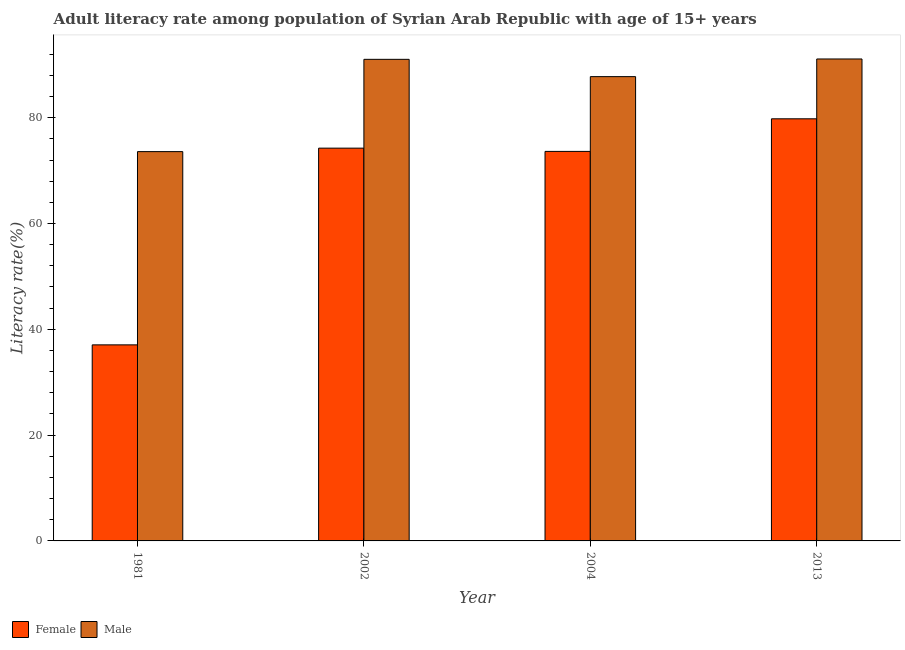How many different coloured bars are there?
Ensure brevity in your answer.  2. How many groups of bars are there?
Give a very brief answer. 4. Are the number of bars on each tick of the X-axis equal?
Give a very brief answer. Yes. How many bars are there on the 2nd tick from the left?
Ensure brevity in your answer.  2. What is the label of the 1st group of bars from the left?
Your response must be concise. 1981. In how many cases, is the number of bars for a given year not equal to the number of legend labels?
Provide a succinct answer. 0. What is the male adult literacy rate in 2002?
Your response must be concise. 91.03. Across all years, what is the maximum female adult literacy rate?
Your response must be concise. 79.79. Across all years, what is the minimum female adult literacy rate?
Make the answer very short. 37.06. What is the total male adult literacy rate in the graph?
Provide a succinct answer. 343.47. What is the difference between the male adult literacy rate in 2004 and that in 2013?
Make the answer very short. -3.34. What is the difference between the female adult literacy rate in 1981 and the male adult literacy rate in 2002?
Give a very brief answer. -37.18. What is the average female adult literacy rate per year?
Your response must be concise. 66.18. In the year 2004, what is the difference between the female adult literacy rate and male adult literacy rate?
Provide a succinct answer. 0. What is the ratio of the male adult literacy rate in 2002 to that in 2004?
Offer a terse response. 1.04. Is the female adult literacy rate in 1981 less than that in 2004?
Offer a very short reply. Yes. What is the difference between the highest and the second highest female adult literacy rate?
Provide a short and direct response. 5.55. What is the difference between the highest and the lowest female adult literacy rate?
Keep it short and to the point. 42.73. In how many years, is the female adult literacy rate greater than the average female adult literacy rate taken over all years?
Provide a short and direct response. 3. Is the sum of the male adult literacy rate in 2002 and 2004 greater than the maximum female adult literacy rate across all years?
Offer a terse response. Yes. What does the 2nd bar from the right in 2002 represents?
Give a very brief answer. Female. How many bars are there?
Offer a terse response. 8. Are all the bars in the graph horizontal?
Provide a short and direct response. No. Does the graph contain grids?
Make the answer very short. No. Where does the legend appear in the graph?
Provide a succinct answer. Bottom left. How many legend labels are there?
Provide a short and direct response. 2. What is the title of the graph?
Give a very brief answer. Adult literacy rate among population of Syrian Arab Republic with age of 15+ years. Does "Time to import" appear as one of the legend labels in the graph?
Provide a succinct answer. No. What is the label or title of the X-axis?
Give a very brief answer. Year. What is the label or title of the Y-axis?
Keep it short and to the point. Literacy rate(%). What is the Literacy rate(%) in Female in 1981?
Keep it short and to the point. 37.06. What is the Literacy rate(%) in Male in 1981?
Ensure brevity in your answer.  73.58. What is the Literacy rate(%) in Female in 2002?
Offer a very short reply. 74.24. What is the Literacy rate(%) of Male in 2002?
Give a very brief answer. 91.03. What is the Literacy rate(%) in Female in 2004?
Offer a terse response. 73.63. What is the Literacy rate(%) of Male in 2004?
Your answer should be very brief. 87.76. What is the Literacy rate(%) of Female in 2013?
Keep it short and to the point. 79.79. What is the Literacy rate(%) in Male in 2013?
Make the answer very short. 91.1. Across all years, what is the maximum Literacy rate(%) of Female?
Offer a terse response. 79.79. Across all years, what is the maximum Literacy rate(%) of Male?
Offer a very short reply. 91.1. Across all years, what is the minimum Literacy rate(%) in Female?
Give a very brief answer. 37.06. Across all years, what is the minimum Literacy rate(%) in Male?
Make the answer very short. 73.58. What is the total Literacy rate(%) in Female in the graph?
Ensure brevity in your answer.  264.71. What is the total Literacy rate(%) in Male in the graph?
Provide a short and direct response. 343.47. What is the difference between the Literacy rate(%) of Female in 1981 and that in 2002?
Your answer should be very brief. -37.18. What is the difference between the Literacy rate(%) in Male in 1981 and that in 2002?
Offer a very short reply. -17.44. What is the difference between the Literacy rate(%) of Female in 1981 and that in 2004?
Provide a short and direct response. -36.57. What is the difference between the Literacy rate(%) in Male in 1981 and that in 2004?
Offer a terse response. -14.17. What is the difference between the Literacy rate(%) in Female in 1981 and that in 2013?
Provide a short and direct response. -42.73. What is the difference between the Literacy rate(%) in Male in 1981 and that in 2013?
Give a very brief answer. -17.51. What is the difference between the Literacy rate(%) of Female in 2002 and that in 2004?
Provide a succinct answer. 0.61. What is the difference between the Literacy rate(%) of Male in 2002 and that in 2004?
Your answer should be very brief. 3.27. What is the difference between the Literacy rate(%) of Female in 2002 and that in 2013?
Make the answer very short. -5.55. What is the difference between the Literacy rate(%) in Male in 2002 and that in 2013?
Your answer should be compact. -0.07. What is the difference between the Literacy rate(%) in Female in 2004 and that in 2013?
Provide a short and direct response. -6.16. What is the difference between the Literacy rate(%) of Male in 2004 and that in 2013?
Give a very brief answer. -3.34. What is the difference between the Literacy rate(%) in Female in 1981 and the Literacy rate(%) in Male in 2002?
Offer a terse response. -53.97. What is the difference between the Literacy rate(%) of Female in 1981 and the Literacy rate(%) of Male in 2004?
Keep it short and to the point. -50.7. What is the difference between the Literacy rate(%) in Female in 1981 and the Literacy rate(%) in Male in 2013?
Provide a succinct answer. -54.04. What is the difference between the Literacy rate(%) of Female in 2002 and the Literacy rate(%) of Male in 2004?
Give a very brief answer. -13.52. What is the difference between the Literacy rate(%) of Female in 2002 and the Literacy rate(%) of Male in 2013?
Provide a short and direct response. -16.86. What is the difference between the Literacy rate(%) in Female in 2004 and the Literacy rate(%) in Male in 2013?
Ensure brevity in your answer.  -17.47. What is the average Literacy rate(%) in Female per year?
Provide a short and direct response. 66.18. What is the average Literacy rate(%) in Male per year?
Your answer should be very brief. 85.87. In the year 1981, what is the difference between the Literacy rate(%) in Female and Literacy rate(%) in Male?
Offer a terse response. -36.53. In the year 2002, what is the difference between the Literacy rate(%) of Female and Literacy rate(%) of Male?
Offer a terse response. -16.79. In the year 2004, what is the difference between the Literacy rate(%) of Female and Literacy rate(%) of Male?
Make the answer very short. -14.13. In the year 2013, what is the difference between the Literacy rate(%) of Female and Literacy rate(%) of Male?
Provide a short and direct response. -11.31. What is the ratio of the Literacy rate(%) of Female in 1981 to that in 2002?
Keep it short and to the point. 0.5. What is the ratio of the Literacy rate(%) in Male in 1981 to that in 2002?
Your answer should be compact. 0.81. What is the ratio of the Literacy rate(%) in Female in 1981 to that in 2004?
Keep it short and to the point. 0.5. What is the ratio of the Literacy rate(%) of Male in 1981 to that in 2004?
Provide a succinct answer. 0.84. What is the ratio of the Literacy rate(%) of Female in 1981 to that in 2013?
Ensure brevity in your answer.  0.46. What is the ratio of the Literacy rate(%) in Male in 1981 to that in 2013?
Offer a terse response. 0.81. What is the ratio of the Literacy rate(%) in Female in 2002 to that in 2004?
Make the answer very short. 1.01. What is the ratio of the Literacy rate(%) of Male in 2002 to that in 2004?
Offer a very short reply. 1.04. What is the ratio of the Literacy rate(%) in Female in 2002 to that in 2013?
Provide a short and direct response. 0.93. What is the ratio of the Literacy rate(%) of Male in 2002 to that in 2013?
Provide a short and direct response. 1. What is the ratio of the Literacy rate(%) in Female in 2004 to that in 2013?
Ensure brevity in your answer.  0.92. What is the ratio of the Literacy rate(%) in Male in 2004 to that in 2013?
Provide a short and direct response. 0.96. What is the difference between the highest and the second highest Literacy rate(%) of Female?
Provide a short and direct response. 5.55. What is the difference between the highest and the second highest Literacy rate(%) of Male?
Your answer should be compact. 0.07. What is the difference between the highest and the lowest Literacy rate(%) of Female?
Make the answer very short. 42.73. What is the difference between the highest and the lowest Literacy rate(%) of Male?
Ensure brevity in your answer.  17.51. 